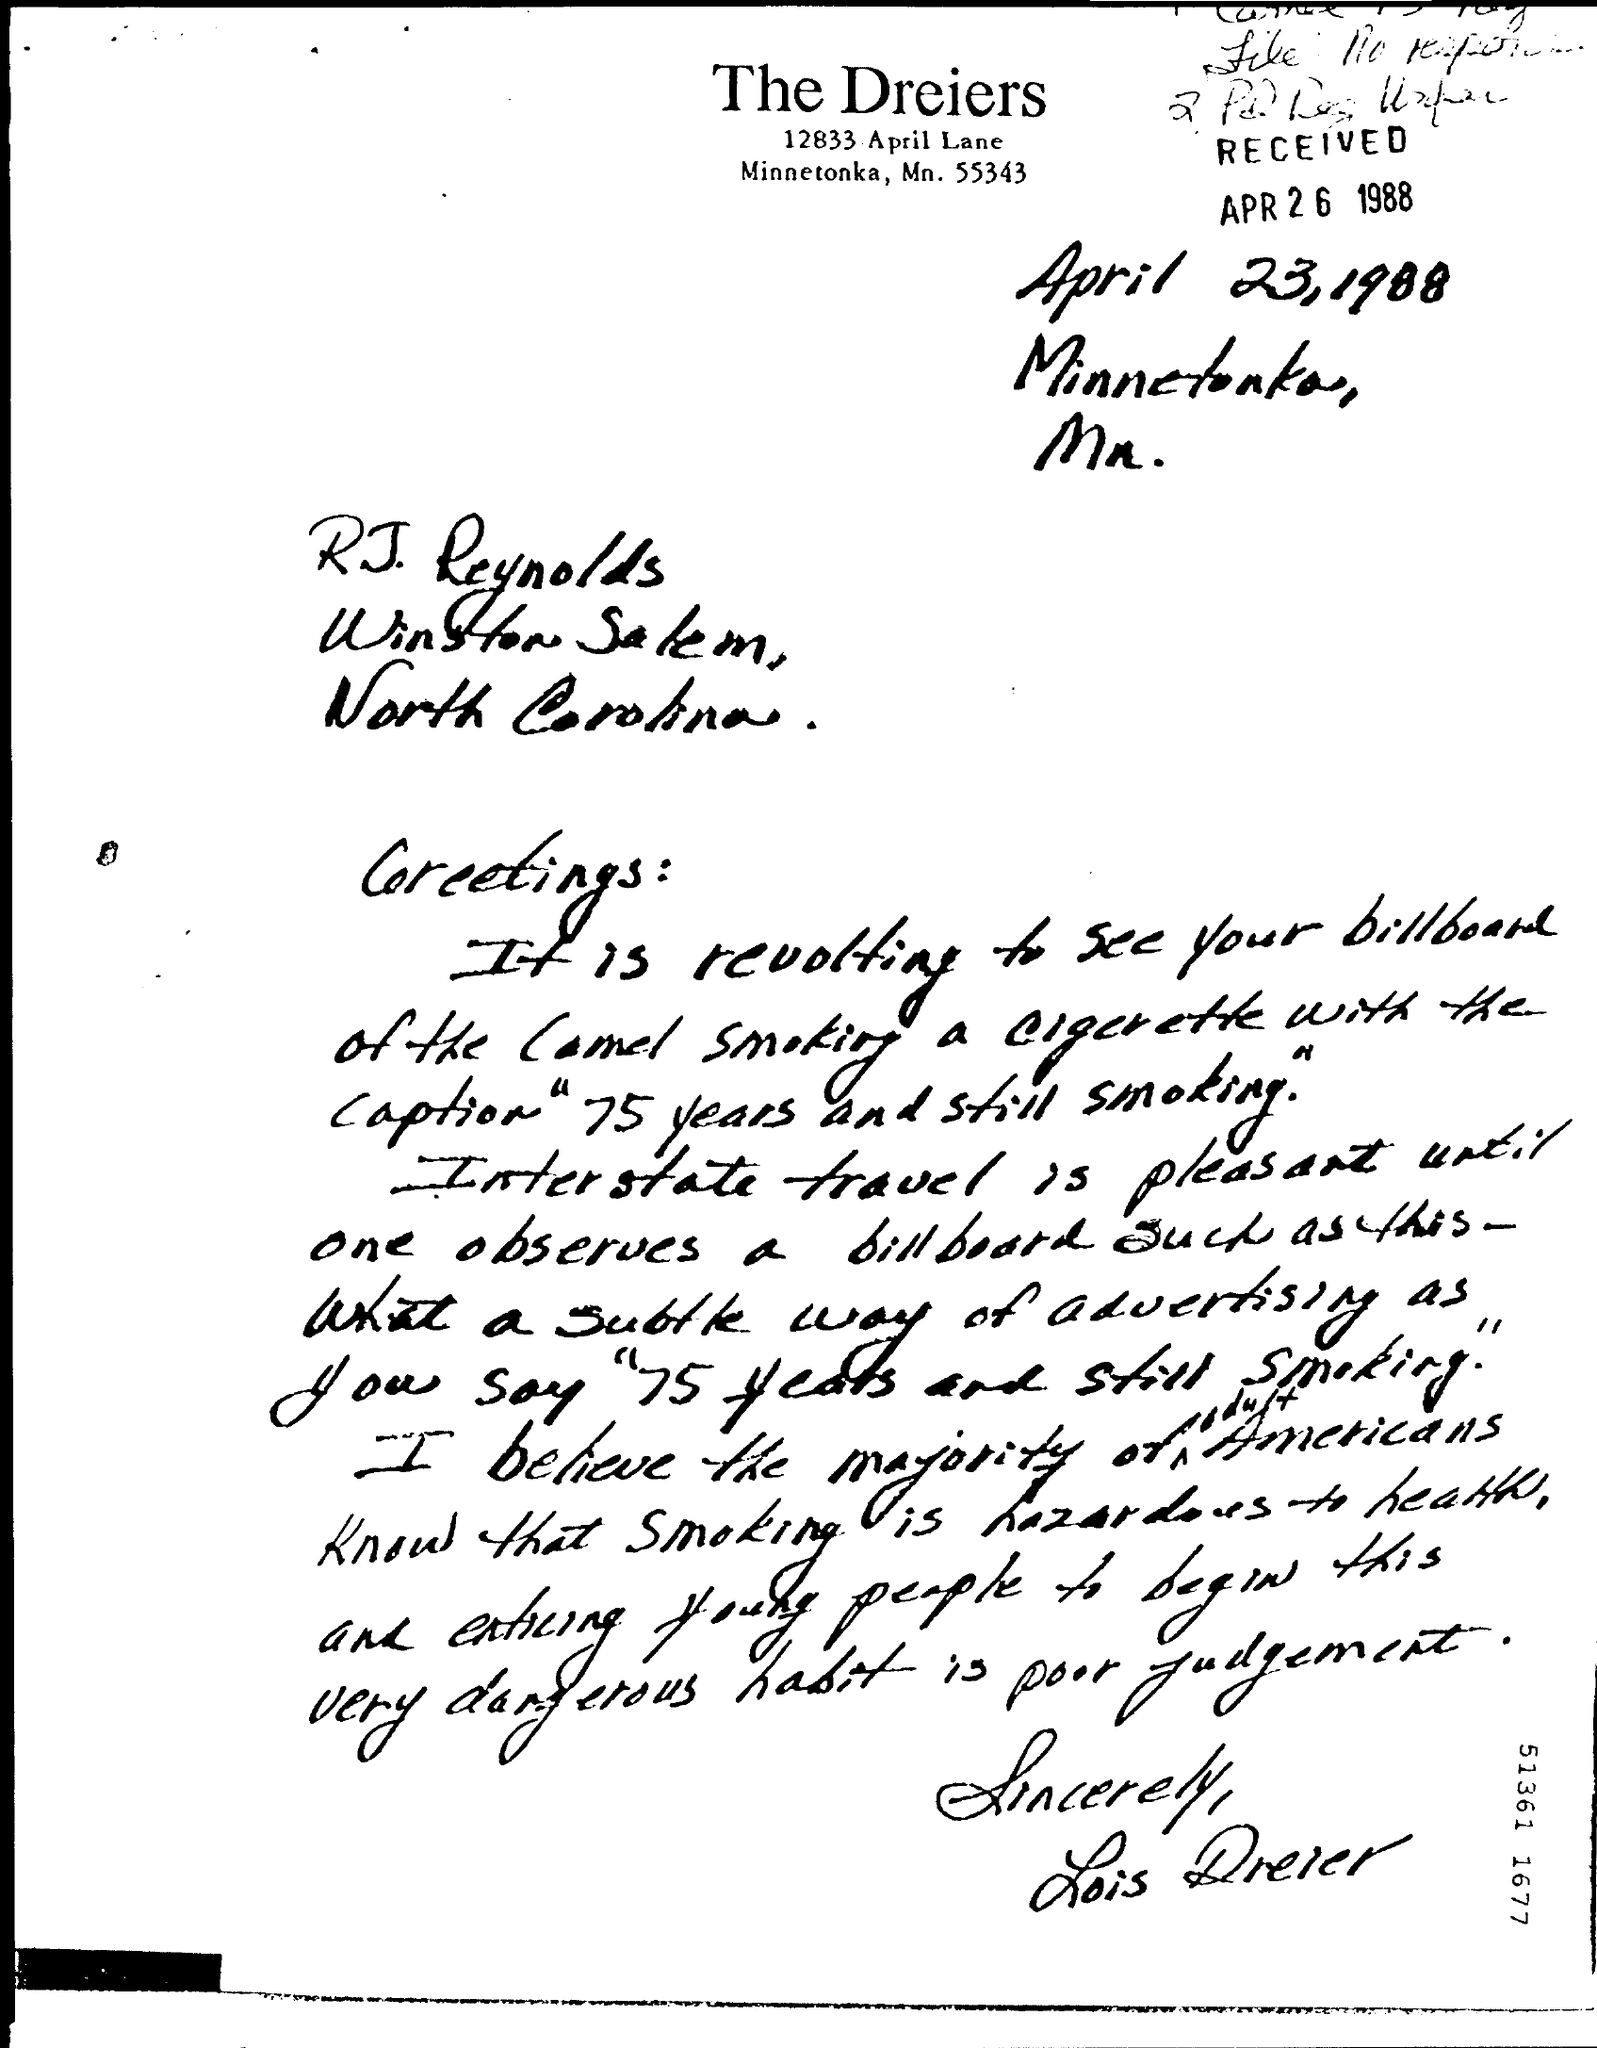Outline some significant characteristics in this image. The person who has signed the letter at the end is Lois Dreier. On what date was this letter received? The letter was received on April 26, 1988. The letter was written on April 23, 1988. 